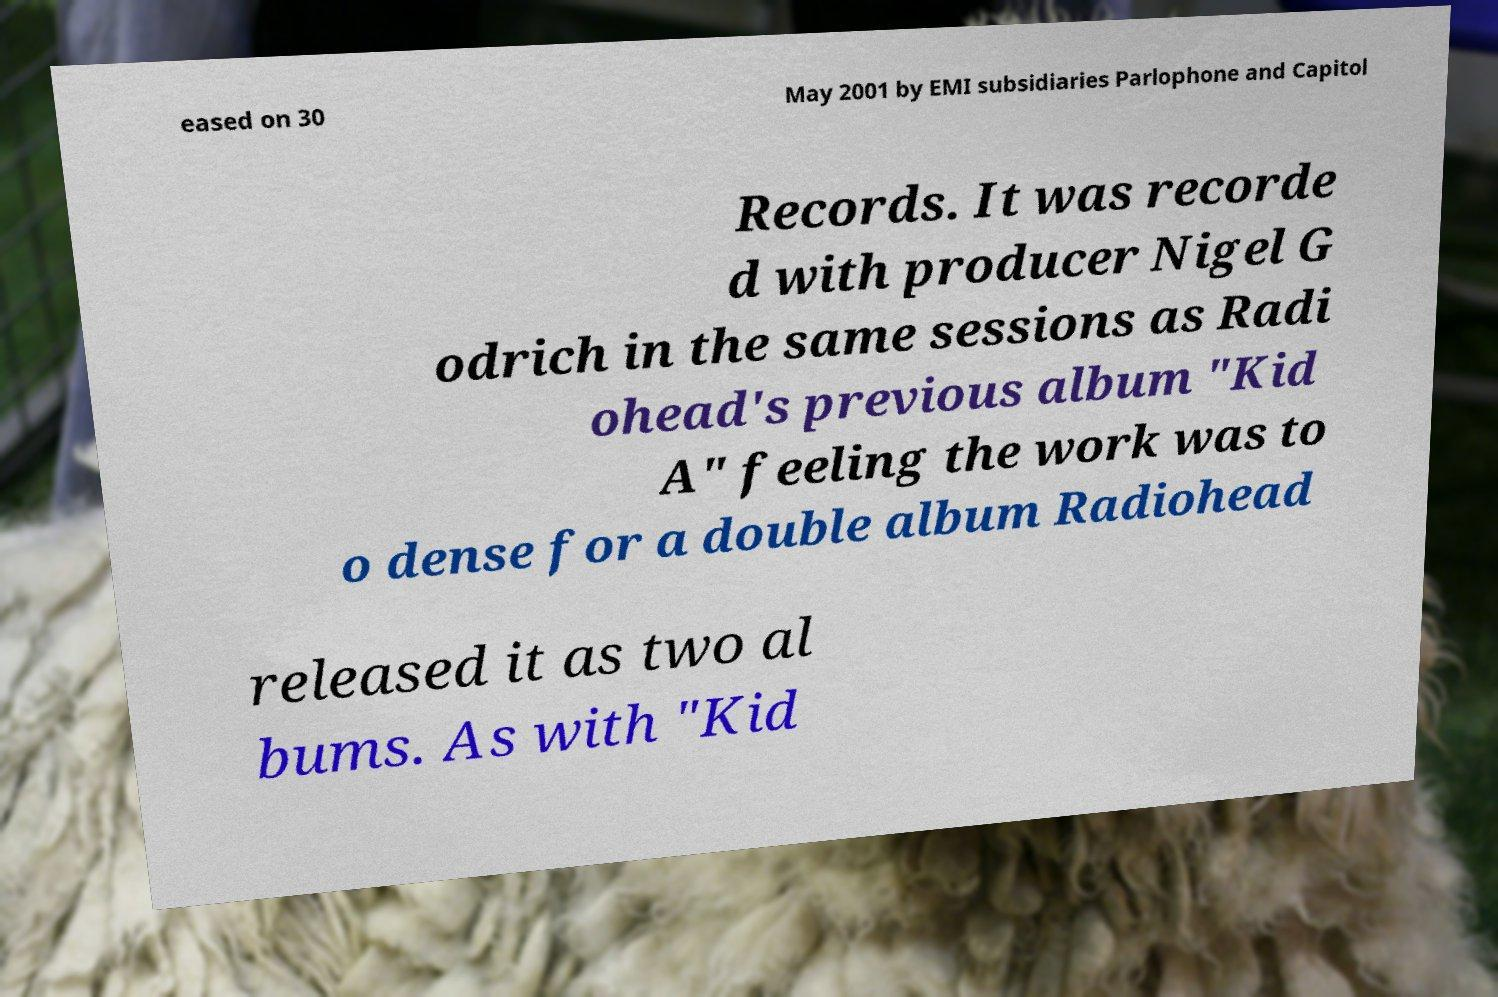There's text embedded in this image that I need extracted. Can you transcribe it verbatim? eased on 30 May 2001 by EMI subsidiaries Parlophone and Capitol Records. It was recorde d with producer Nigel G odrich in the same sessions as Radi ohead's previous album "Kid A" feeling the work was to o dense for a double album Radiohead released it as two al bums. As with "Kid 